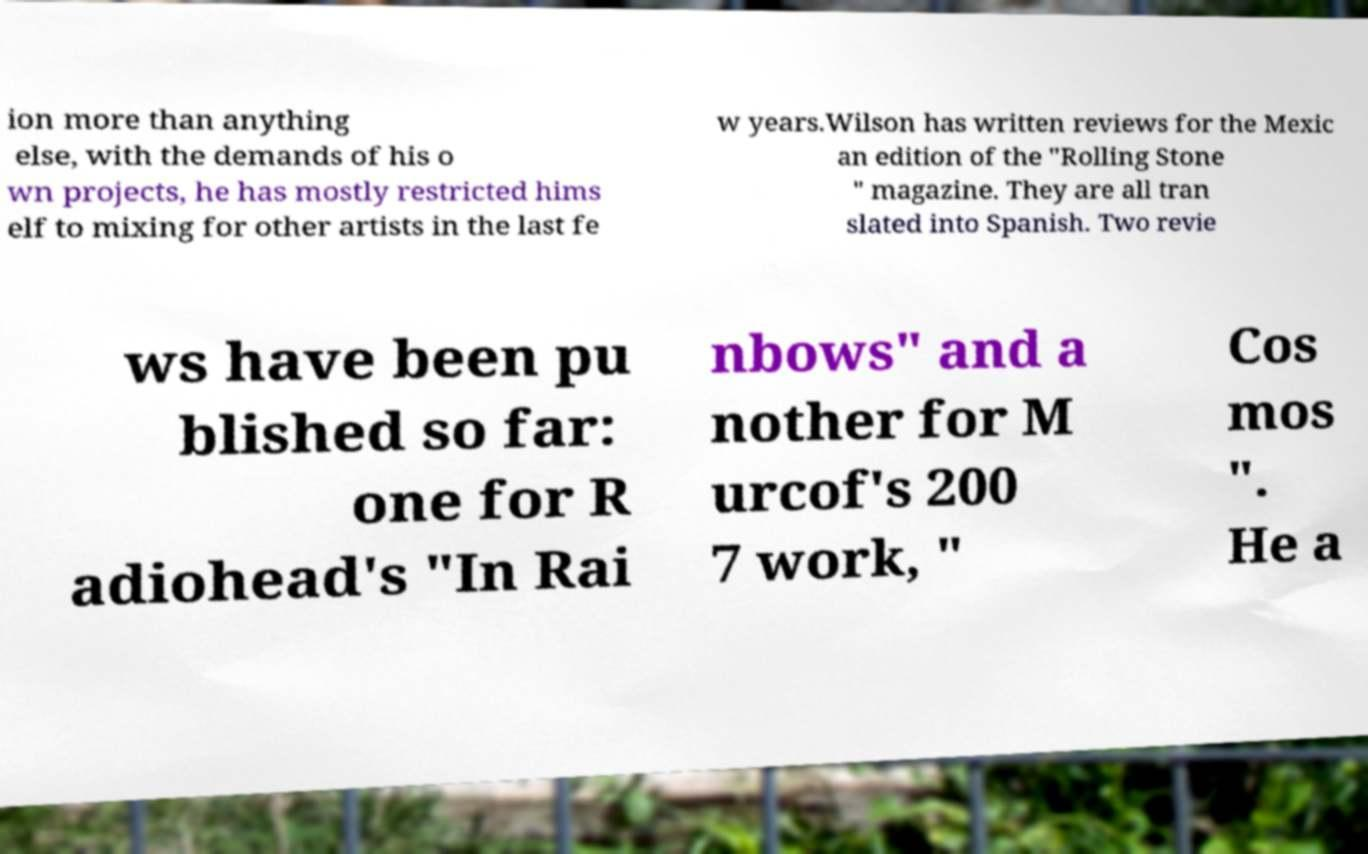Could you extract and type out the text from this image? ion more than anything else, with the demands of his o wn projects, he has mostly restricted hims elf to mixing for other artists in the last fe w years.Wilson has written reviews for the Mexic an edition of the "Rolling Stone " magazine. They are all tran slated into Spanish. Two revie ws have been pu blished so far: one for R adiohead's "In Rai nbows" and a nother for M urcof's 200 7 work, " Cos mos ". He a 